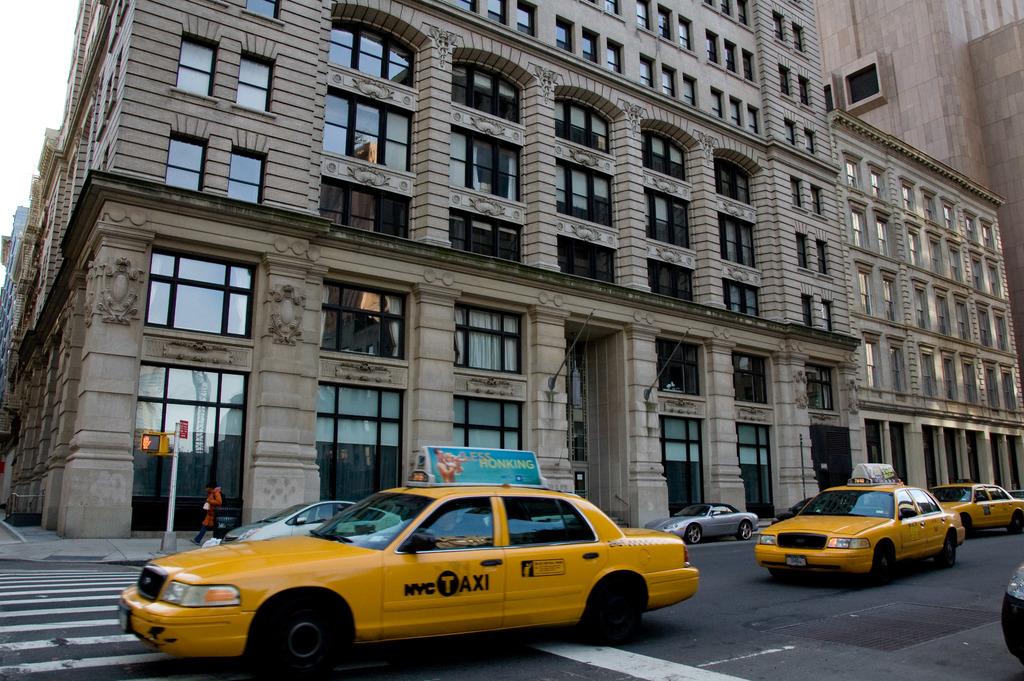What city are these people driving in?
Provide a short and direct response. Nyc. In which city are these taxis driving?
Give a very brief answer. Nyc. 